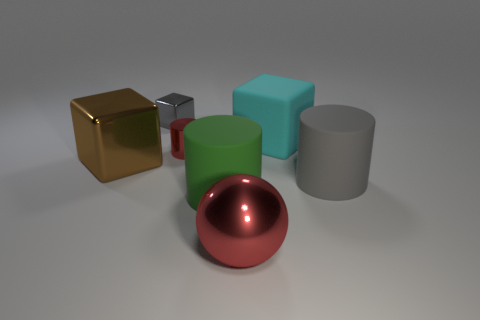Subtract all big rubber cylinders. How many cylinders are left? 1 Subtract 2 cubes. How many cubes are left? 1 Add 3 large green metallic cubes. How many objects exist? 10 Subtract all shiny balls. Subtract all small metal blocks. How many objects are left? 5 Add 6 large gray matte cylinders. How many large gray matte cylinders are left? 7 Add 2 rubber things. How many rubber things exist? 5 Subtract 1 cyan cubes. How many objects are left? 6 Subtract all balls. How many objects are left? 6 Subtract all cyan cylinders. Subtract all yellow spheres. How many cylinders are left? 3 